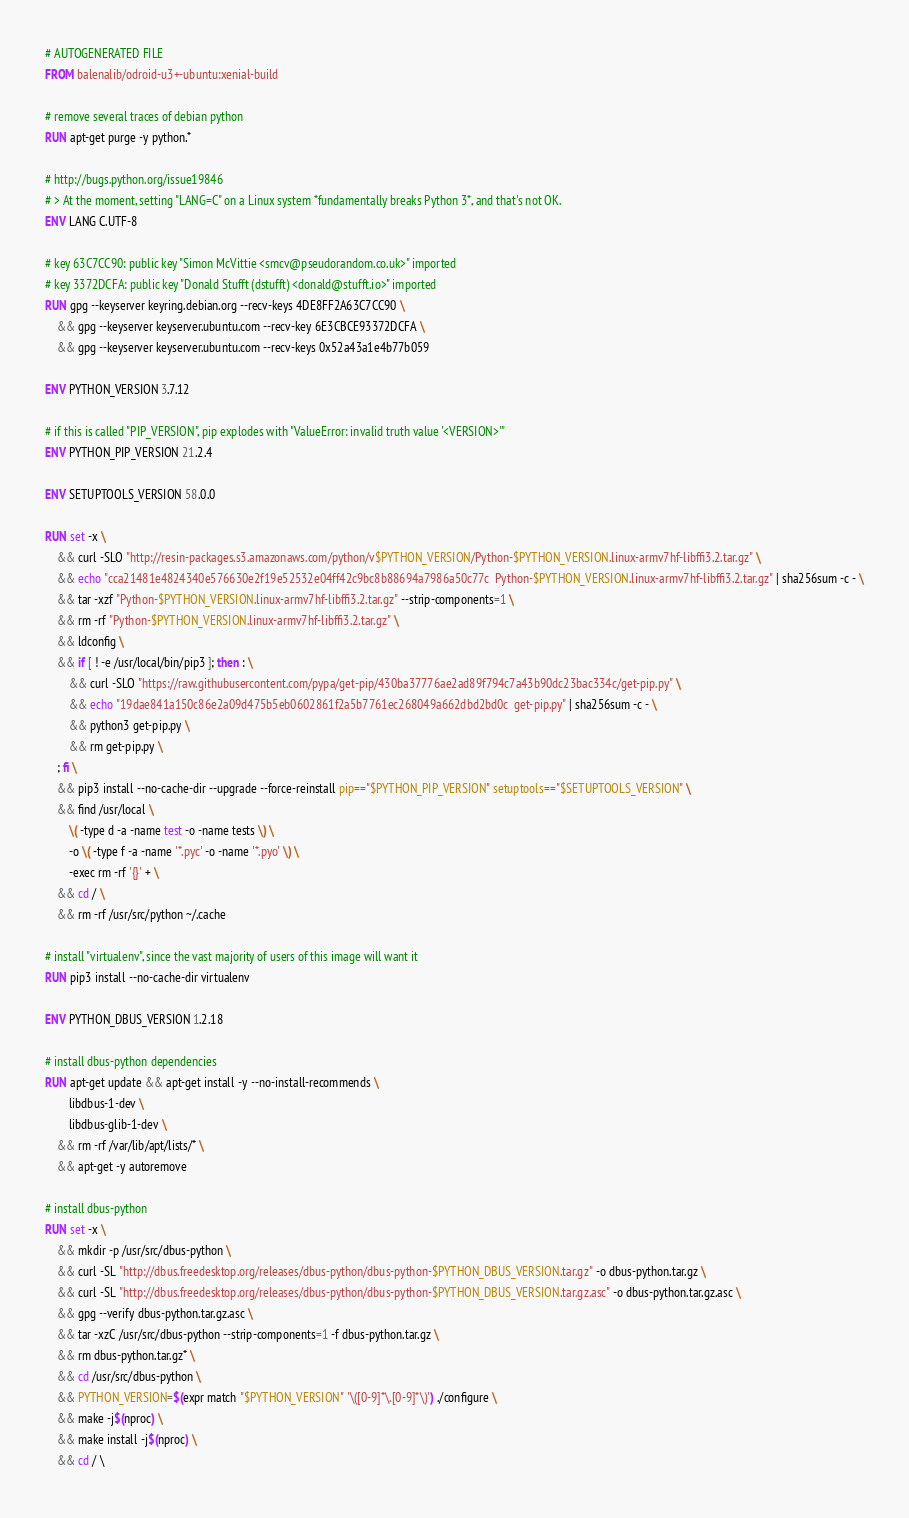<code> <loc_0><loc_0><loc_500><loc_500><_Dockerfile_># AUTOGENERATED FILE
FROM balenalib/odroid-u3+-ubuntu:xenial-build

# remove several traces of debian python
RUN apt-get purge -y python.*

# http://bugs.python.org/issue19846
# > At the moment, setting "LANG=C" on a Linux system *fundamentally breaks Python 3*, and that's not OK.
ENV LANG C.UTF-8

# key 63C7CC90: public key "Simon McVittie <smcv@pseudorandom.co.uk>" imported
# key 3372DCFA: public key "Donald Stufft (dstufft) <donald@stufft.io>" imported
RUN gpg --keyserver keyring.debian.org --recv-keys 4DE8FF2A63C7CC90 \
	&& gpg --keyserver keyserver.ubuntu.com --recv-key 6E3CBCE93372DCFA \
	&& gpg --keyserver keyserver.ubuntu.com --recv-keys 0x52a43a1e4b77b059

ENV PYTHON_VERSION 3.7.12

# if this is called "PIP_VERSION", pip explodes with "ValueError: invalid truth value '<VERSION>'"
ENV PYTHON_PIP_VERSION 21.2.4

ENV SETUPTOOLS_VERSION 58.0.0

RUN set -x \
	&& curl -SLO "http://resin-packages.s3.amazonaws.com/python/v$PYTHON_VERSION/Python-$PYTHON_VERSION.linux-armv7hf-libffi3.2.tar.gz" \
	&& echo "cca21481e4824340e576630e2f19e52532e04ff42c9bc8b88694a7986a50c77c  Python-$PYTHON_VERSION.linux-armv7hf-libffi3.2.tar.gz" | sha256sum -c - \
	&& tar -xzf "Python-$PYTHON_VERSION.linux-armv7hf-libffi3.2.tar.gz" --strip-components=1 \
	&& rm -rf "Python-$PYTHON_VERSION.linux-armv7hf-libffi3.2.tar.gz" \
	&& ldconfig \
	&& if [ ! -e /usr/local/bin/pip3 ]; then : \
		&& curl -SLO "https://raw.githubusercontent.com/pypa/get-pip/430ba37776ae2ad89f794c7a43b90dc23bac334c/get-pip.py" \
		&& echo "19dae841a150c86e2a09d475b5eb0602861f2a5b7761ec268049a662dbd2bd0c  get-pip.py" | sha256sum -c - \
		&& python3 get-pip.py \
		&& rm get-pip.py \
	; fi \
	&& pip3 install --no-cache-dir --upgrade --force-reinstall pip=="$PYTHON_PIP_VERSION" setuptools=="$SETUPTOOLS_VERSION" \
	&& find /usr/local \
		\( -type d -a -name test -o -name tests \) \
		-o \( -type f -a -name '*.pyc' -o -name '*.pyo' \) \
		-exec rm -rf '{}' + \
	&& cd / \
	&& rm -rf /usr/src/python ~/.cache

# install "virtualenv", since the vast majority of users of this image will want it
RUN pip3 install --no-cache-dir virtualenv

ENV PYTHON_DBUS_VERSION 1.2.18

# install dbus-python dependencies 
RUN apt-get update && apt-get install -y --no-install-recommends \
		libdbus-1-dev \
		libdbus-glib-1-dev \
	&& rm -rf /var/lib/apt/lists/* \
	&& apt-get -y autoremove

# install dbus-python
RUN set -x \
	&& mkdir -p /usr/src/dbus-python \
	&& curl -SL "http://dbus.freedesktop.org/releases/dbus-python/dbus-python-$PYTHON_DBUS_VERSION.tar.gz" -o dbus-python.tar.gz \
	&& curl -SL "http://dbus.freedesktop.org/releases/dbus-python/dbus-python-$PYTHON_DBUS_VERSION.tar.gz.asc" -o dbus-python.tar.gz.asc \
	&& gpg --verify dbus-python.tar.gz.asc \
	&& tar -xzC /usr/src/dbus-python --strip-components=1 -f dbus-python.tar.gz \
	&& rm dbus-python.tar.gz* \
	&& cd /usr/src/dbus-python \
	&& PYTHON_VERSION=$(expr match "$PYTHON_VERSION" '\([0-9]*\.[0-9]*\)') ./configure \
	&& make -j$(nproc) \
	&& make install -j$(nproc) \
	&& cd / \</code> 